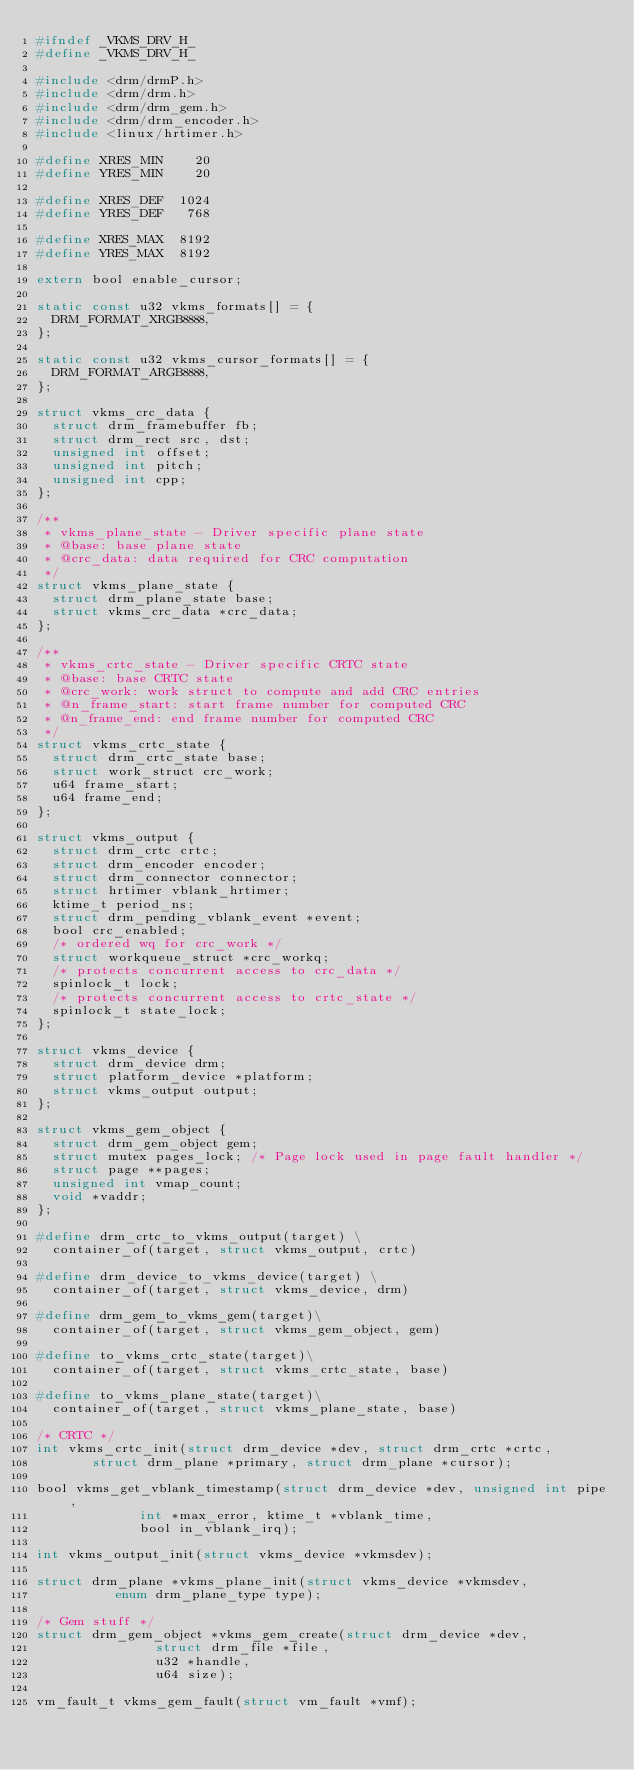<code> <loc_0><loc_0><loc_500><loc_500><_C_>#ifndef _VKMS_DRV_H_
#define _VKMS_DRV_H_

#include <drm/drmP.h>
#include <drm/drm.h>
#include <drm/drm_gem.h>
#include <drm/drm_encoder.h>
#include <linux/hrtimer.h>

#define XRES_MIN    20
#define YRES_MIN    20

#define XRES_DEF  1024
#define YRES_DEF   768

#define XRES_MAX  8192
#define YRES_MAX  8192

extern bool enable_cursor;

static const u32 vkms_formats[] = {
	DRM_FORMAT_XRGB8888,
};

static const u32 vkms_cursor_formats[] = {
	DRM_FORMAT_ARGB8888,
};

struct vkms_crc_data {
	struct drm_framebuffer fb;
	struct drm_rect src, dst;
	unsigned int offset;
	unsigned int pitch;
	unsigned int cpp;
};

/**
 * vkms_plane_state - Driver specific plane state
 * @base: base plane state
 * @crc_data: data required for CRC computation
 */
struct vkms_plane_state {
	struct drm_plane_state base;
	struct vkms_crc_data *crc_data;
};

/**
 * vkms_crtc_state - Driver specific CRTC state
 * @base: base CRTC state
 * @crc_work: work struct to compute and add CRC entries
 * @n_frame_start: start frame number for computed CRC
 * @n_frame_end: end frame number for computed CRC
 */
struct vkms_crtc_state {
	struct drm_crtc_state base;
	struct work_struct crc_work;
	u64 frame_start;
	u64 frame_end;
};

struct vkms_output {
	struct drm_crtc crtc;
	struct drm_encoder encoder;
	struct drm_connector connector;
	struct hrtimer vblank_hrtimer;
	ktime_t period_ns;
	struct drm_pending_vblank_event *event;
	bool crc_enabled;
	/* ordered wq for crc_work */
	struct workqueue_struct *crc_workq;
	/* protects concurrent access to crc_data */
	spinlock_t lock;
	/* protects concurrent access to crtc_state */
	spinlock_t state_lock;
};

struct vkms_device {
	struct drm_device drm;
	struct platform_device *platform;
	struct vkms_output output;
};

struct vkms_gem_object {
	struct drm_gem_object gem;
	struct mutex pages_lock; /* Page lock used in page fault handler */
	struct page **pages;
	unsigned int vmap_count;
	void *vaddr;
};

#define drm_crtc_to_vkms_output(target) \
	container_of(target, struct vkms_output, crtc)

#define drm_device_to_vkms_device(target) \
	container_of(target, struct vkms_device, drm)

#define drm_gem_to_vkms_gem(target)\
	container_of(target, struct vkms_gem_object, gem)

#define to_vkms_crtc_state(target)\
	container_of(target, struct vkms_crtc_state, base)

#define to_vkms_plane_state(target)\
	container_of(target, struct vkms_plane_state, base)

/* CRTC */
int vkms_crtc_init(struct drm_device *dev, struct drm_crtc *crtc,
		   struct drm_plane *primary, struct drm_plane *cursor);

bool vkms_get_vblank_timestamp(struct drm_device *dev, unsigned int pipe,
			       int *max_error, ktime_t *vblank_time,
			       bool in_vblank_irq);

int vkms_output_init(struct vkms_device *vkmsdev);

struct drm_plane *vkms_plane_init(struct vkms_device *vkmsdev,
				  enum drm_plane_type type);

/* Gem stuff */
struct drm_gem_object *vkms_gem_create(struct drm_device *dev,
				       struct drm_file *file,
				       u32 *handle,
				       u64 size);

vm_fault_t vkms_gem_fault(struct vm_fault *vmf);
</code> 